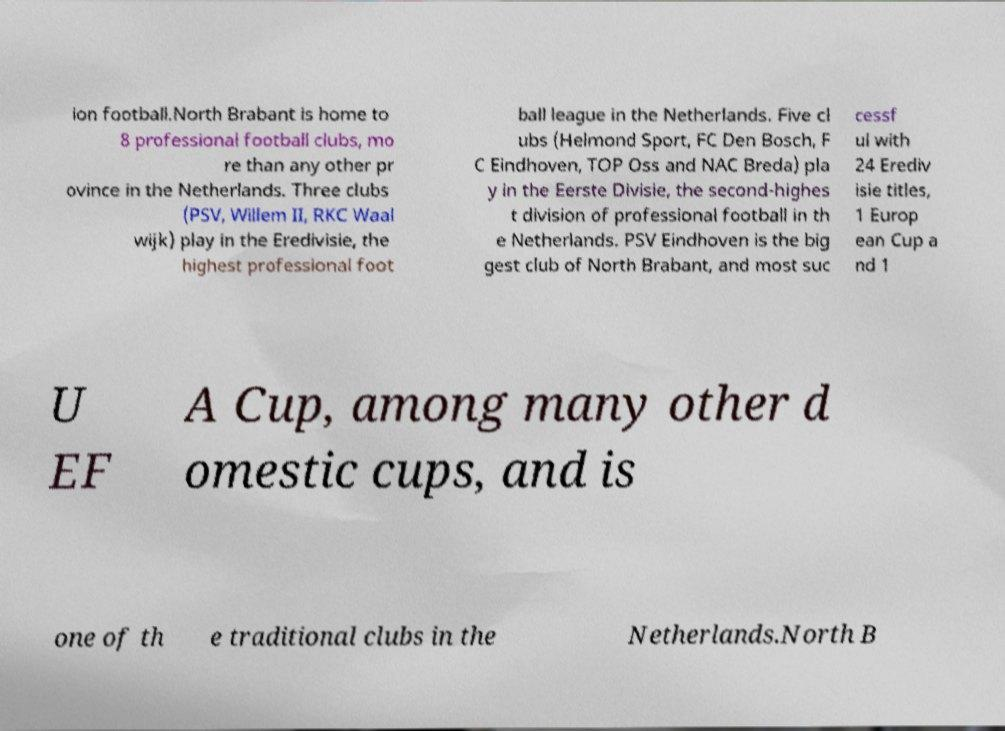Please identify and transcribe the text found in this image. ion football.North Brabant is home to 8 professional football clubs, mo re than any other pr ovince in the Netherlands. Three clubs (PSV, Willem II, RKC Waal wijk) play in the Eredivisie, the highest professional foot ball league in the Netherlands. Five cl ubs (Helmond Sport, FC Den Bosch, F C Eindhoven, TOP Oss and NAC Breda) pla y in the Eerste Divisie, the second-highes t division of professional football in th e Netherlands. PSV Eindhoven is the big gest club of North Brabant, and most suc cessf ul with 24 Erediv isie titles, 1 Europ ean Cup a nd 1 U EF A Cup, among many other d omestic cups, and is one of th e traditional clubs in the Netherlands.North B 